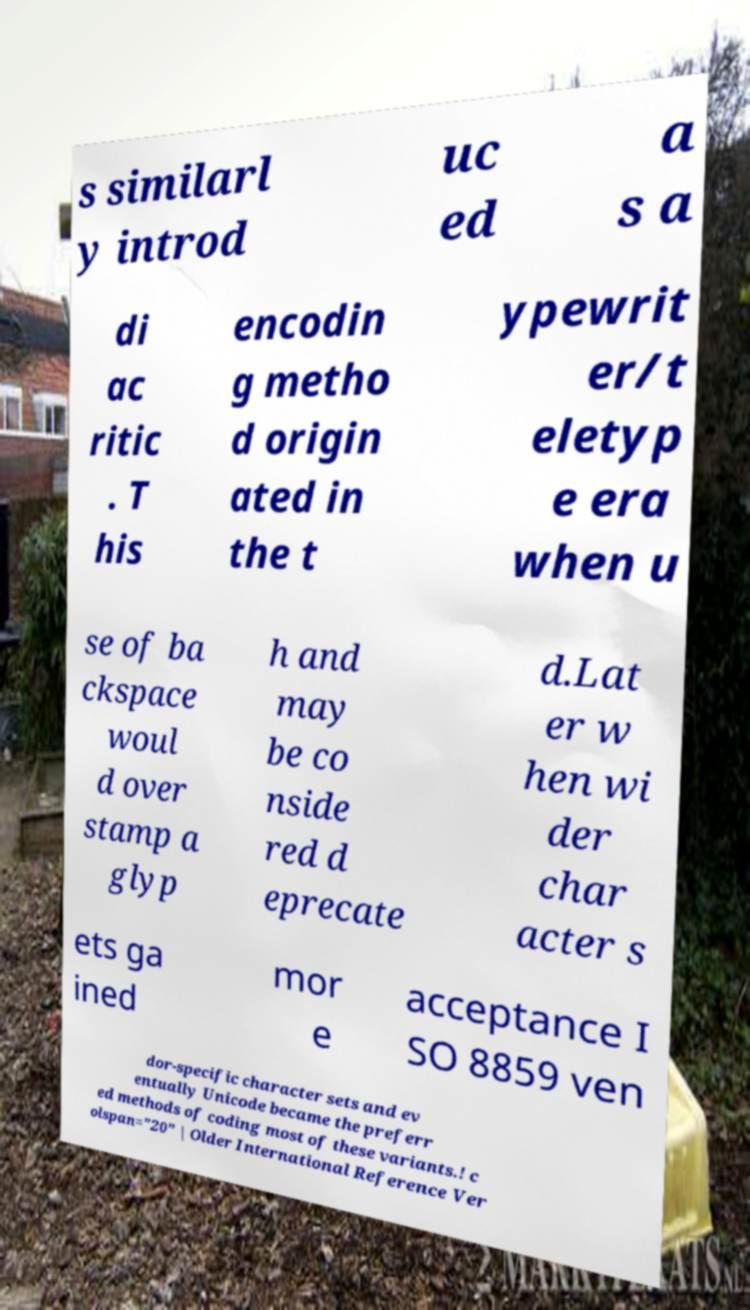Could you extract and type out the text from this image? s similarl y introd uc ed a s a di ac ritic . T his encodin g metho d origin ated in the t ypewrit er/t eletyp e era when u se of ba ckspace woul d over stamp a glyp h and may be co nside red d eprecate d.Lat er w hen wi der char acter s ets ga ined mor e acceptance I SO 8859 ven dor-specific character sets and ev entually Unicode became the preferr ed methods of coding most of these variants.! c olspan="20" | Older International Reference Ver 